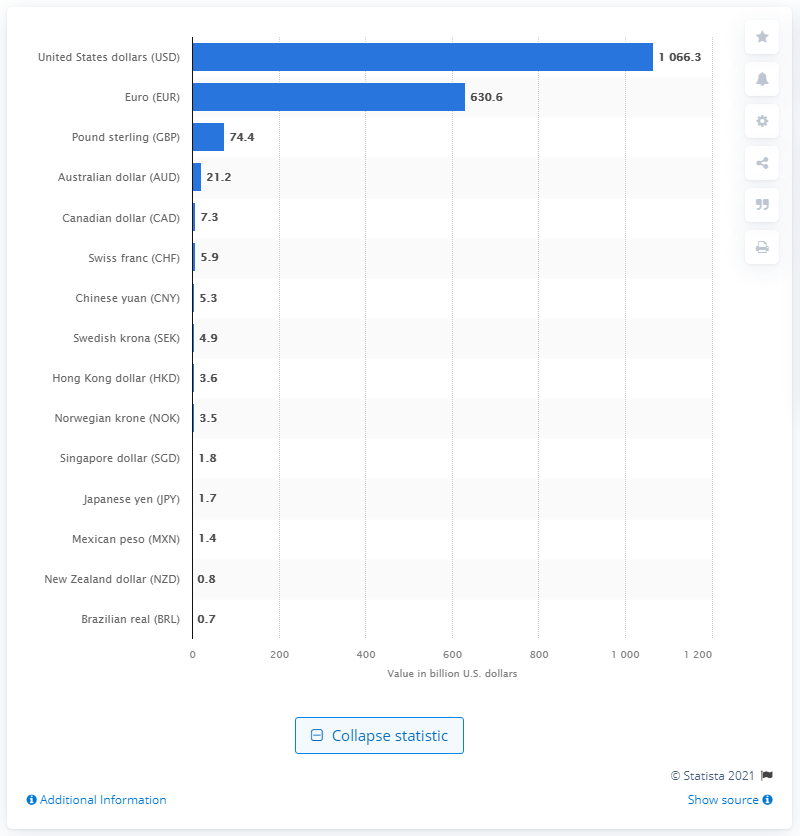Highlight a few significant elements in this photo. In 2021, the value of deals in the U.S. dollar was 1066.3. 